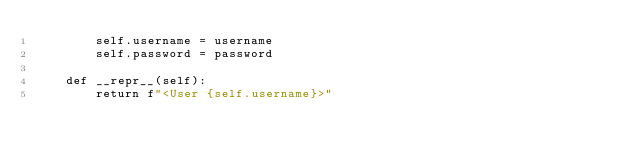<code> <loc_0><loc_0><loc_500><loc_500><_Python_>        self.username = username
        self.password = password

    def __repr__(self):
        return f"<User {self.username}>"
</code> 